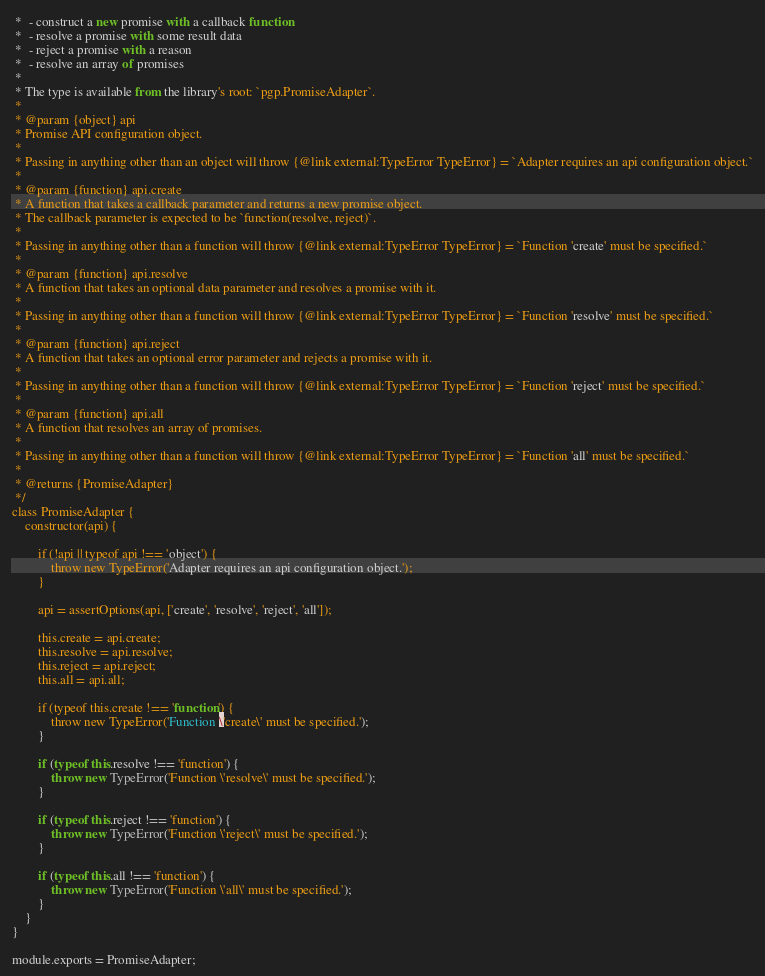<code> <loc_0><loc_0><loc_500><loc_500><_JavaScript_> *  - construct a new promise with a callback function
 *  - resolve a promise with some result data
 *  - reject a promise with a reason
 *  - resolve an array of promises
 *
 * The type is available from the library's root: `pgp.PromiseAdapter`.
 *
 * @param {object} api
 * Promise API configuration object.
 *
 * Passing in anything other than an object will throw {@link external:TypeError TypeError} = `Adapter requires an api configuration object.`
 *
 * @param {function} api.create
 * A function that takes a callback parameter and returns a new promise object.
 * The callback parameter is expected to be `function(resolve, reject)`.
 *
 * Passing in anything other than a function will throw {@link external:TypeError TypeError} = `Function 'create' must be specified.`
 *
 * @param {function} api.resolve
 * A function that takes an optional data parameter and resolves a promise with it.
 *
 * Passing in anything other than a function will throw {@link external:TypeError TypeError} = `Function 'resolve' must be specified.`
 *
 * @param {function} api.reject
 * A function that takes an optional error parameter and rejects a promise with it.
 *
 * Passing in anything other than a function will throw {@link external:TypeError TypeError} = `Function 'reject' must be specified.`
 *
 * @param {function} api.all
 * A function that resolves an array of promises.
 *
 * Passing in anything other than a function will throw {@link external:TypeError TypeError} = `Function 'all' must be specified.`
 *
 * @returns {PromiseAdapter}
 */
class PromiseAdapter {
    constructor(api) {

        if (!api || typeof api !== 'object') {
            throw new TypeError('Adapter requires an api configuration object.');
        }

        api = assertOptions(api, ['create', 'resolve', 'reject', 'all']);

        this.create = api.create;
        this.resolve = api.resolve;
        this.reject = api.reject;
        this.all = api.all;

        if (typeof this.create !== 'function') {
            throw new TypeError('Function \'create\' must be specified.');
        }

        if (typeof this.resolve !== 'function') {
            throw new TypeError('Function \'resolve\' must be specified.');
        }

        if (typeof this.reject !== 'function') {
            throw new TypeError('Function \'reject\' must be specified.');
        }

        if (typeof this.all !== 'function') {
            throw new TypeError('Function \'all\' must be specified.');
        }
    }
}

module.exports = PromiseAdapter;
</code> 